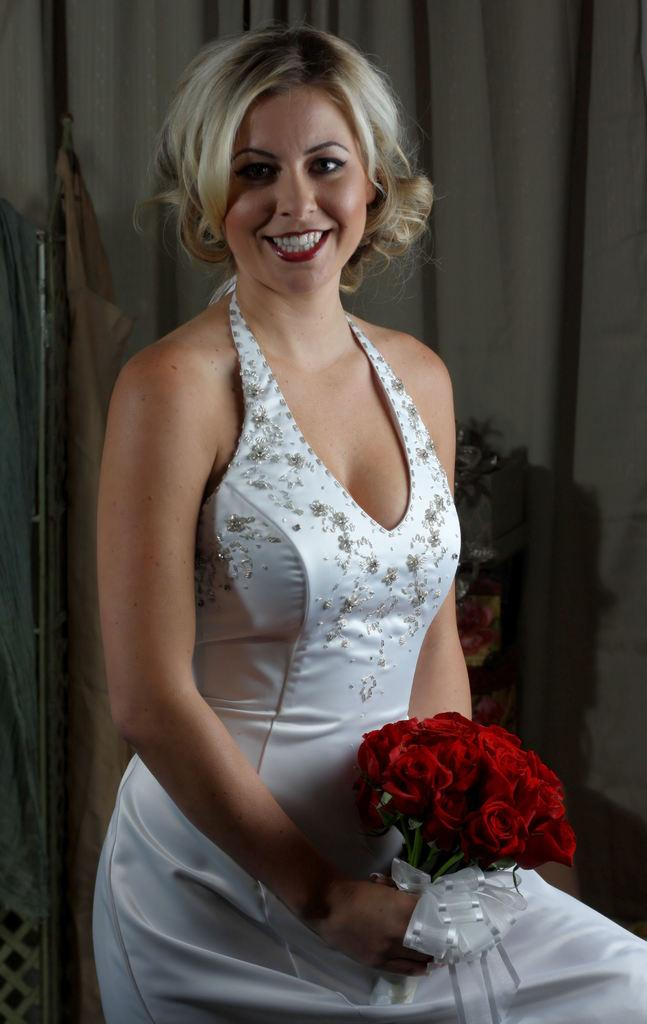Who is present in the image? There is a woman in the image. What is the woman holding in the image? The woman is holding red color flowers. What can be seen in the background of the image? There is a curtain, a wall, clothes, and other objects in the background of the image. How many quarters can be seen in the woman's stomach in the image? There are no quarters visible in the image, nor is there any indication of the woman's stomach being shown. 